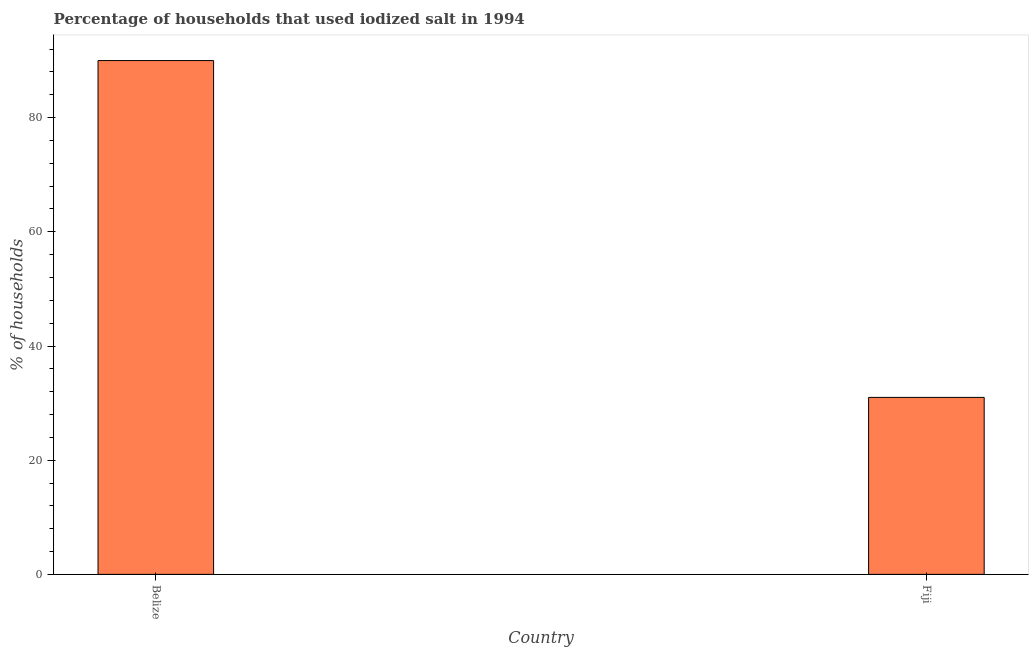Does the graph contain any zero values?
Offer a terse response. No. Does the graph contain grids?
Provide a succinct answer. No. What is the title of the graph?
Give a very brief answer. Percentage of households that used iodized salt in 1994. What is the label or title of the Y-axis?
Your answer should be compact. % of households. In which country was the percentage of households where iodized salt is consumed maximum?
Keep it short and to the point. Belize. In which country was the percentage of households where iodized salt is consumed minimum?
Your response must be concise. Fiji. What is the sum of the percentage of households where iodized salt is consumed?
Keep it short and to the point. 121. What is the difference between the percentage of households where iodized salt is consumed in Belize and Fiji?
Offer a very short reply. 59. What is the average percentage of households where iodized salt is consumed per country?
Your answer should be very brief. 60. What is the median percentage of households where iodized salt is consumed?
Provide a succinct answer. 60.5. What is the ratio of the percentage of households where iodized salt is consumed in Belize to that in Fiji?
Your answer should be very brief. 2.9. Is the percentage of households where iodized salt is consumed in Belize less than that in Fiji?
Give a very brief answer. No. In how many countries, is the percentage of households where iodized salt is consumed greater than the average percentage of households where iodized salt is consumed taken over all countries?
Provide a short and direct response. 1. How many countries are there in the graph?
Make the answer very short. 2. What is the difference between two consecutive major ticks on the Y-axis?
Your answer should be very brief. 20. What is the % of households in Fiji?
Keep it short and to the point. 31. What is the difference between the % of households in Belize and Fiji?
Give a very brief answer. 59. What is the ratio of the % of households in Belize to that in Fiji?
Provide a short and direct response. 2.9. 